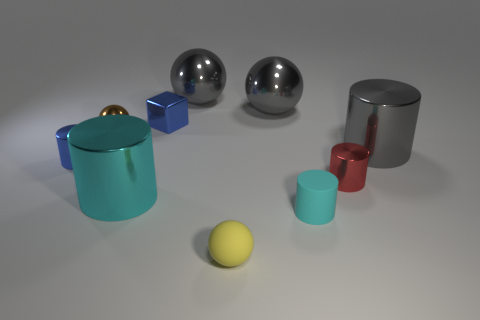There is a blue block that is the same size as the brown metal thing; what material is it? Based on the image, both the blue block and the brown object appear to be made of metal due to their reflections and textures which are consistent with metallic surfaces. Specifically, they both exhibit smooth surfaces and reflect light in a way that suggests they are metallic. 